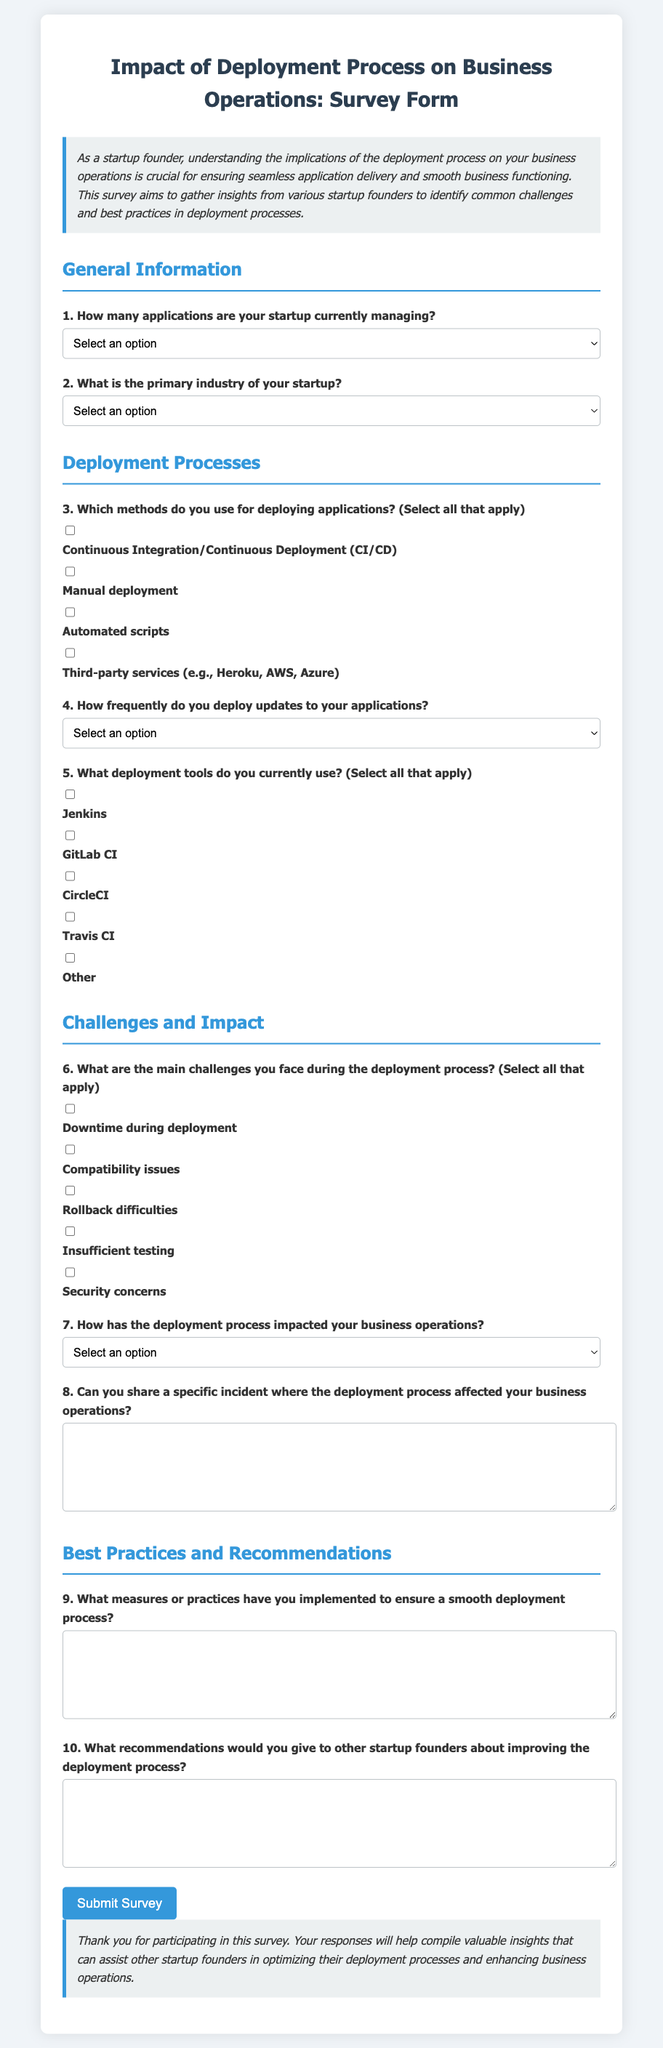What is the title of the survey? The title of the survey is presented in the document, which is "Impact of Deployment Process on Business Operations: Survey Form."
Answer: Impact of Deployment Process on Business Operations: Survey Form How many applications can be selected in question 1? Question 1 provides options for selecting the range of applications managed by the startup. The possible selections are 1-5, 6-10, 11-20, and 21+.
Answer: 4 What is the first option listed under the primary industry of the startup? The first option listed under the primary industry is displayed in the selection for question 2.
Answer: Technology What are the methods for deploying applications mentioned in question 3? Question 3 lists several deployment methods as options which include CI/CD, Manual, Automated scripts, and Third-party services.
Answer: CI/CD, Manual, Automated scripts, Third-party services How often do respondents deploy updates to their applications according to question 4? Question 4 inquires about the frequency of application updates, with options ranging from Daily to Ad-hoc.
Answer: Daily, Weekly, Monthly, Quarterly, Ad-hoc What is one of the main challenges during deployment mentioned in question 6? Question 6 asks about challenges during the deployment process and provides options including Downtime, Compatibility issues, Rollback difficulties, Insufficient testing, and Security concerns.
Answer: Downtime Which deployment tool is listed first in question 5? Question 5 lists available deployment tools, with Jenkins being the first tool mentioned in the checkbox options.
Answer: Jenkins What is the last question regarding recommendations? The last question asks for recommendations that respondents might have for other startup founders to improve the deployment process. This is presented in question 10.
Answer: What recommendations would you give to other startup founders about improving the deployment process? 